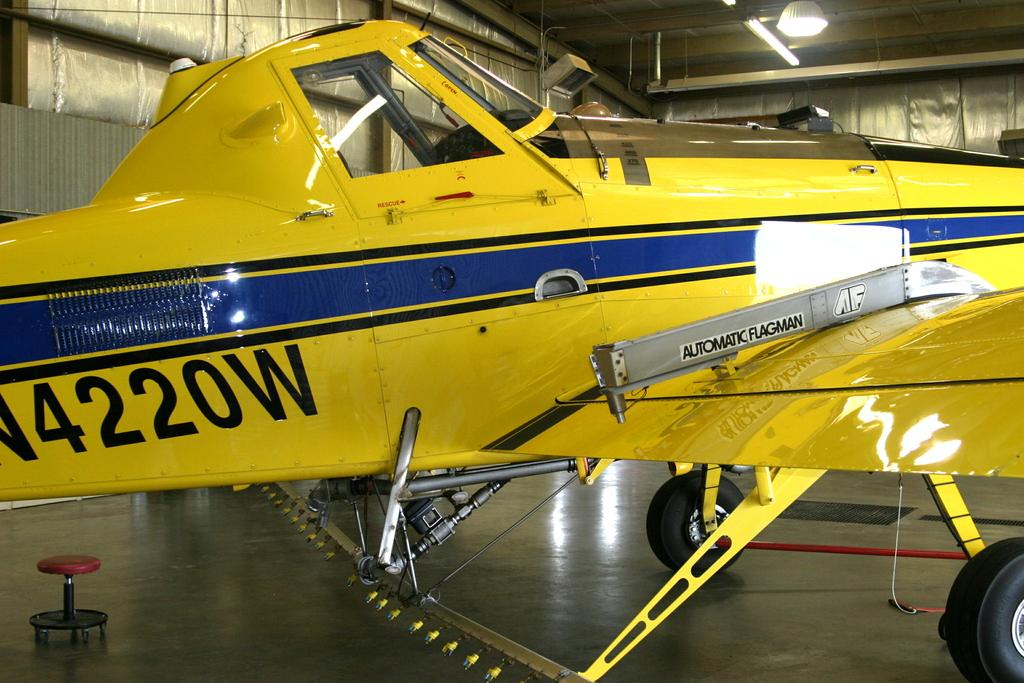Provide a one-sentence caption for the provided image. A yellow plane with a blue stripe on the side with the numbers 4220W. 